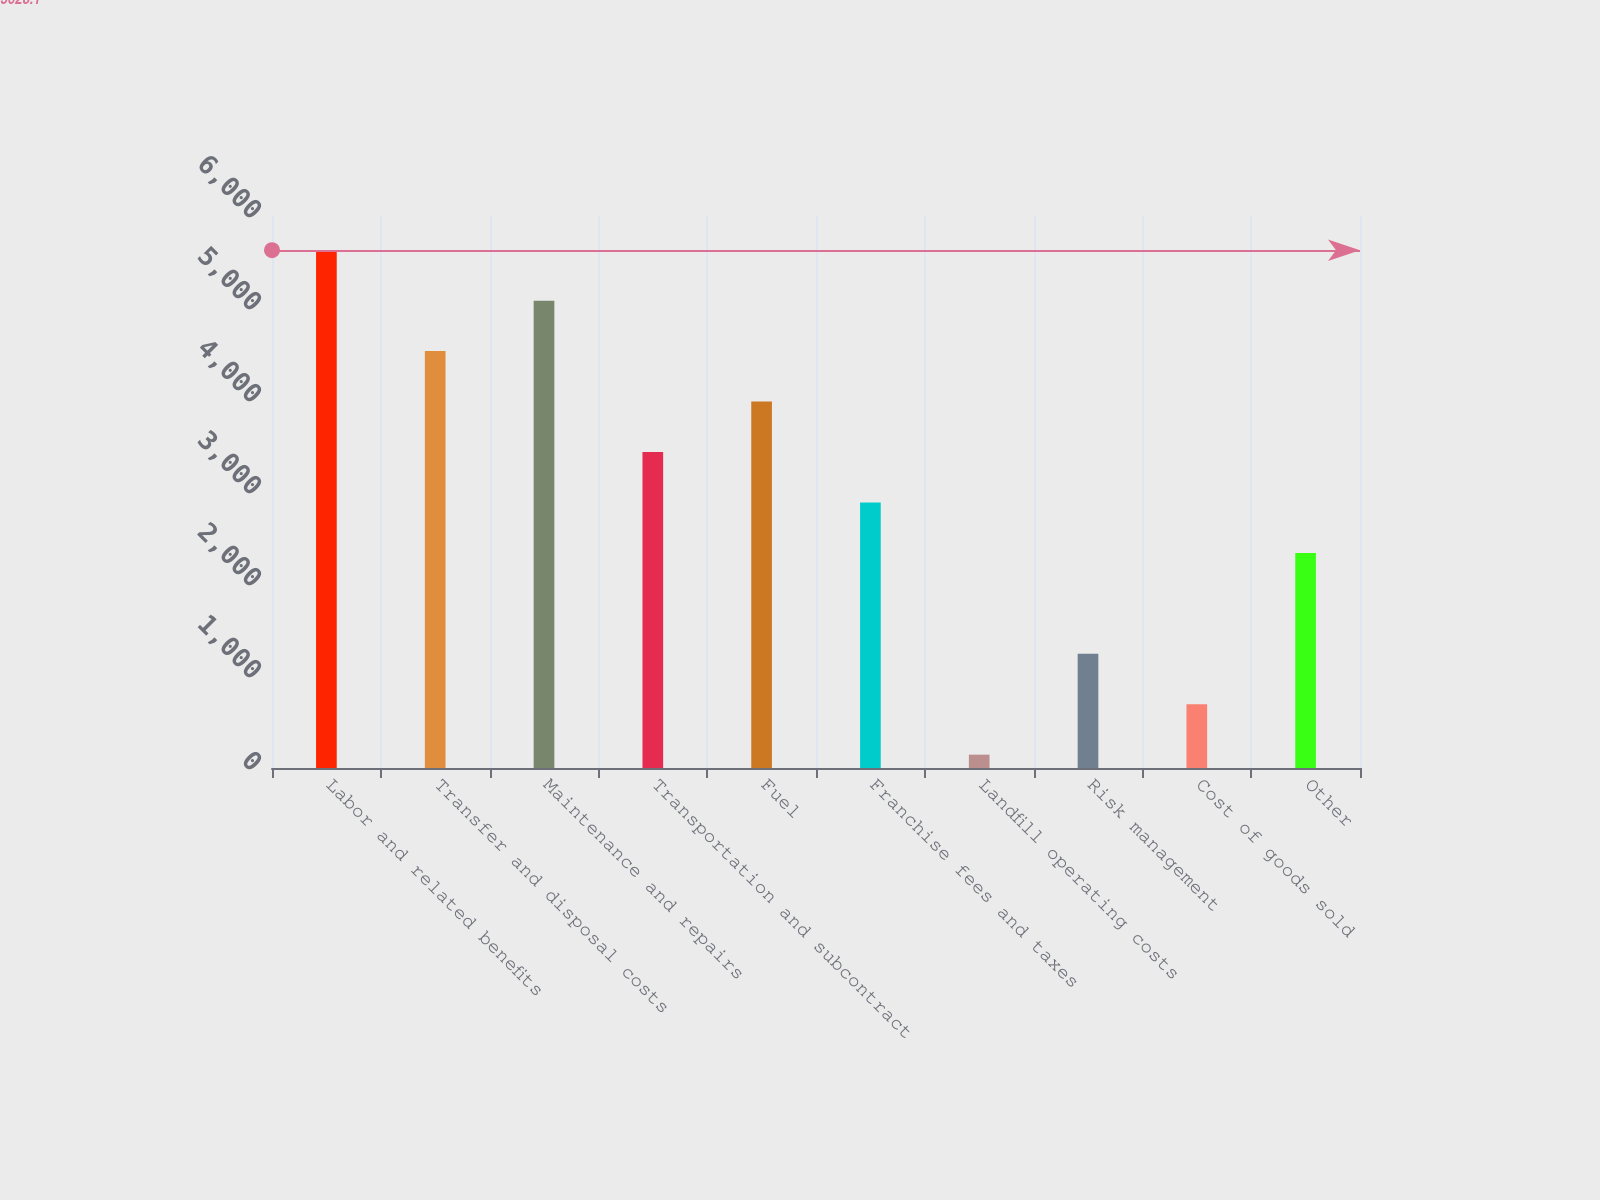Convert chart. <chart><loc_0><loc_0><loc_500><loc_500><bar_chart><fcel>Labor and related benefits<fcel>Transfer and disposal costs<fcel>Maintenance and repairs<fcel>Transportation and subcontract<fcel>Fuel<fcel>Franchise fees and taxes<fcel>Landfill operating costs<fcel>Risk management<fcel>Cost of goods sold<fcel>Other<nl><fcel>5628.1<fcel>4531.5<fcel>5079.8<fcel>3434.9<fcel>3983.2<fcel>2886.6<fcel>145.1<fcel>1241.7<fcel>693.4<fcel>2338.3<nl></chart> 